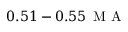<formula> <loc_0><loc_0><loc_500><loc_500>0 . 5 1 - 0 . 5 5 \, M A</formula> 